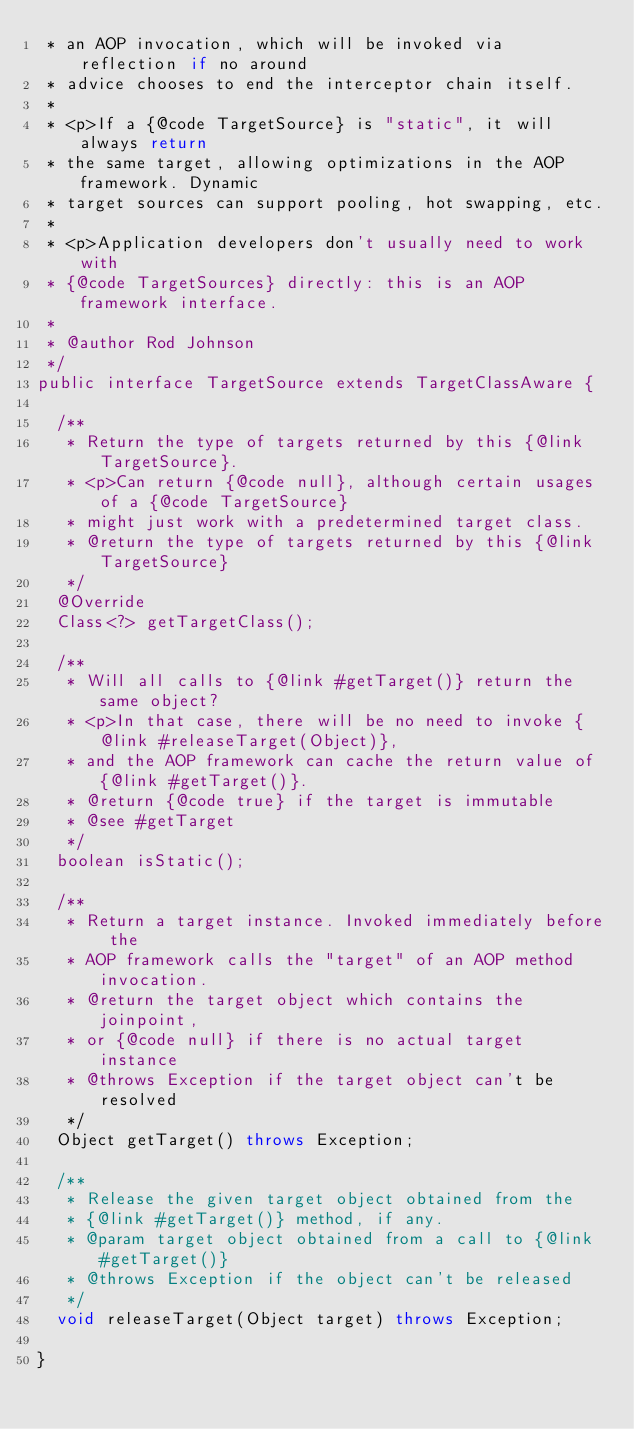Convert code to text. <code><loc_0><loc_0><loc_500><loc_500><_Java_> * an AOP invocation, which will be invoked via reflection if no around
 * advice chooses to end the interceptor chain itself.
 *
 * <p>If a {@code TargetSource} is "static", it will always return
 * the same target, allowing optimizations in the AOP framework. Dynamic
 * target sources can support pooling, hot swapping, etc.
 *
 * <p>Application developers don't usually need to work with
 * {@code TargetSources} directly: this is an AOP framework interface.
 *
 * @author Rod Johnson
 */
public interface TargetSource extends TargetClassAware {

	/**
	 * Return the type of targets returned by this {@link TargetSource}.
	 * <p>Can return {@code null}, although certain usages of a {@code TargetSource}
	 * might just work with a predetermined target class.
	 * @return the type of targets returned by this {@link TargetSource}
	 */
	@Override
	Class<?> getTargetClass();

	/**
	 * Will all calls to {@link #getTarget()} return the same object?
	 * <p>In that case, there will be no need to invoke {@link #releaseTarget(Object)},
	 * and the AOP framework can cache the return value of {@link #getTarget()}.
	 * @return {@code true} if the target is immutable
	 * @see #getTarget
	 */
	boolean isStatic();

	/**
	 * Return a target instance. Invoked immediately before the
	 * AOP framework calls the "target" of an AOP method invocation.
	 * @return the target object which contains the joinpoint,
	 * or {@code null} if there is no actual target instance
	 * @throws Exception if the target object can't be resolved
	 */
	Object getTarget() throws Exception;

	/**
	 * Release the given target object obtained from the
	 * {@link #getTarget()} method, if any.
	 * @param target object obtained from a call to {@link #getTarget()}
	 * @throws Exception if the object can't be released
	 */
	void releaseTarget(Object target) throws Exception;

}
</code> 